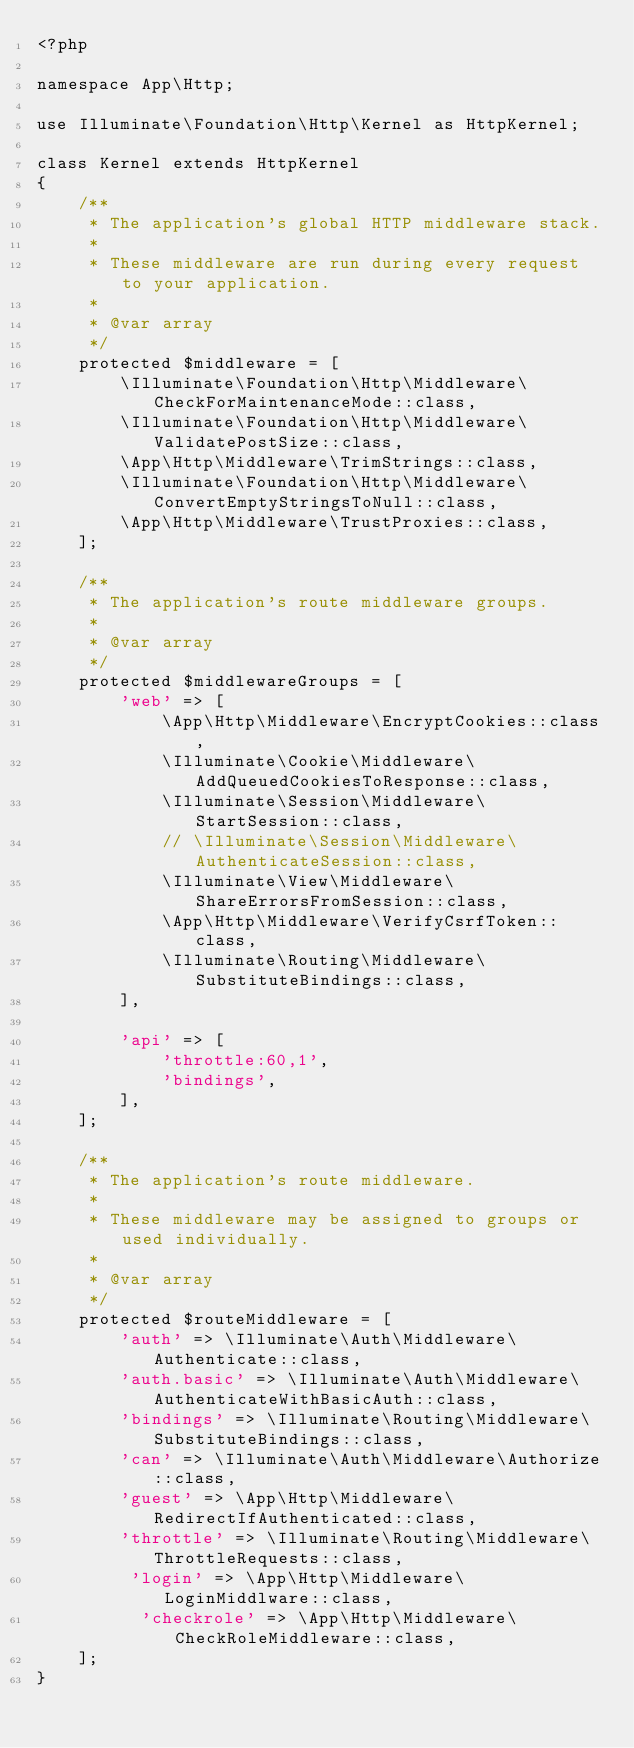<code> <loc_0><loc_0><loc_500><loc_500><_PHP_><?php

namespace App\Http;

use Illuminate\Foundation\Http\Kernel as HttpKernel;

class Kernel extends HttpKernel
{
    /**
     * The application's global HTTP middleware stack.
     *
     * These middleware are run during every request to your application.
     *
     * @var array
     */
    protected $middleware = [
        \Illuminate\Foundation\Http\Middleware\CheckForMaintenanceMode::class,
        \Illuminate\Foundation\Http\Middleware\ValidatePostSize::class,
        \App\Http\Middleware\TrimStrings::class,
        \Illuminate\Foundation\Http\Middleware\ConvertEmptyStringsToNull::class,
        \App\Http\Middleware\TrustProxies::class,
    ];

    /**
     * The application's route middleware groups.
     *
     * @var array
     */
    protected $middlewareGroups = [
        'web' => [
            \App\Http\Middleware\EncryptCookies::class,
            \Illuminate\Cookie\Middleware\AddQueuedCookiesToResponse::class,
            \Illuminate\Session\Middleware\StartSession::class,
            // \Illuminate\Session\Middleware\AuthenticateSession::class,
            \Illuminate\View\Middleware\ShareErrorsFromSession::class,
            \App\Http\Middleware\VerifyCsrfToken::class,
            \Illuminate\Routing\Middleware\SubstituteBindings::class,
        ],

        'api' => [
            'throttle:60,1',
            'bindings',
        ],
    ];

    /**
     * The application's route middleware.
     *
     * These middleware may be assigned to groups or used individually.
     *
     * @var array
     */
    protected $routeMiddleware = [
        'auth' => \Illuminate\Auth\Middleware\Authenticate::class,
        'auth.basic' => \Illuminate\Auth\Middleware\AuthenticateWithBasicAuth::class,
        'bindings' => \Illuminate\Routing\Middleware\SubstituteBindings::class,
        'can' => \Illuminate\Auth\Middleware\Authorize::class,
        'guest' => \App\Http\Middleware\RedirectIfAuthenticated::class,
        'throttle' => \Illuminate\Routing\Middleware\ThrottleRequests::class,
         'login' => \App\Http\Middleware\LoginMiddlware::class,
          'checkrole' => \App\Http\Middleware\CheckRoleMiddleware::class,
    ];
}
</code> 